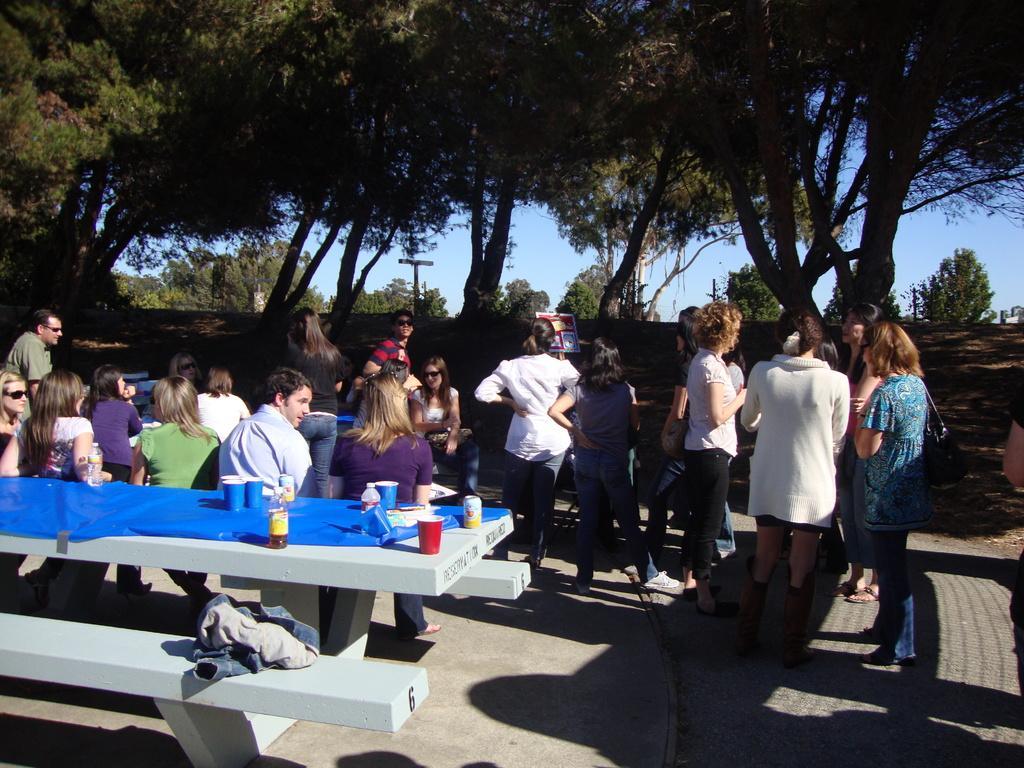How would you summarize this image in a sentence or two? In this image there are group of people, few are standing and few are sitting. There are cups, bottles on the table. At the back there are trees, and at the top there is a sky. 